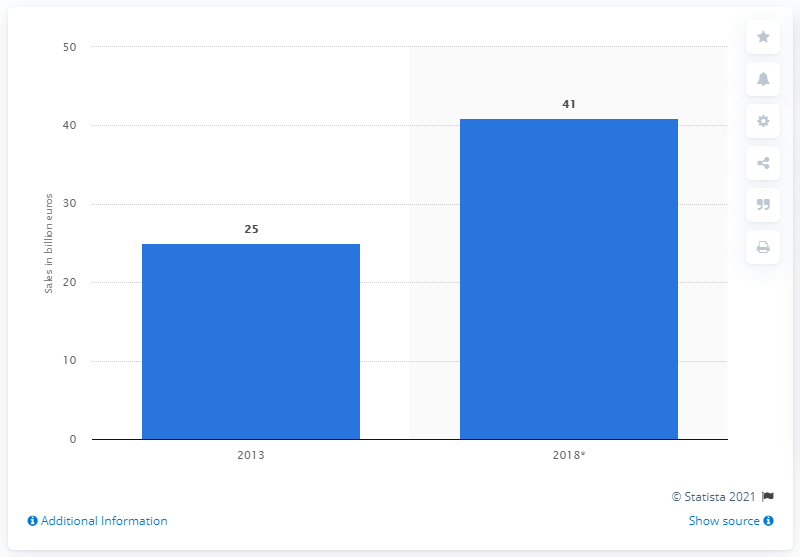List a handful of essential elements in this visual. In 2018, it was projected that online sales would reach a significant growth of 41%. In 2013, online retail sales in Germany were first measured. In 2013, the value of online sales in Germany was approximately 25 billion euros. 